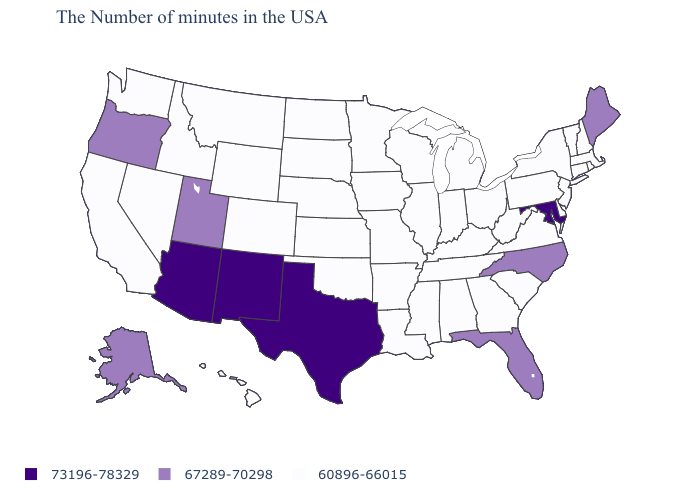How many symbols are there in the legend?
Concise answer only. 3. Name the states that have a value in the range 60896-66015?
Write a very short answer. Massachusetts, Rhode Island, New Hampshire, Vermont, Connecticut, New York, New Jersey, Delaware, Pennsylvania, Virginia, South Carolina, West Virginia, Ohio, Georgia, Michigan, Kentucky, Indiana, Alabama, Tennessee, Wisconsin, Illinois, Mississippi, Louisiana, Missouri, Arkansas, Minnesota, Iowa, Kansas, Nebraska, Oklahoma, South Dakota, North Dakota, Wyoming, Colorado, Montana, Idaho, Nevada, California, Washington, Hawaii. How many symbols are there in the legend?
Give a very brief answer. 3. What is the lowest value in the South?
Write a very short answer. 60896-66015. What is the value of Washington?
Give a very brief answer. 60896-66015. Is the legend a continuous bar?
Answer briefly. No. Name the states that have a value in the range 73196-78329?
Answer briefly. Maryland, Texas, New Mexico, Arizona. What is the value of Alabama?
Be succinct. 60896-66015. Does New Hampshire have a lower value than Oregon?
Concise answer only. Yes. Name the states that have a value in the range 73196-78329?
Give a very brief answer. Maryland, Texas, New Mexico, Arizona. What is the lowest value in states that border Arizona?
Be succinct. 60896-66015. Does Virginia have the highest value in the South?
Be succinct. No. Does Arizona have the highest value in the USA?
Write a very short answer. Yes. 